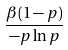Convert formula to latex. <formula><loc_0><loc_0><loc_500><loc_500>\frac { \beta ( 1 - p ) } { - p \ln p }</formula> 